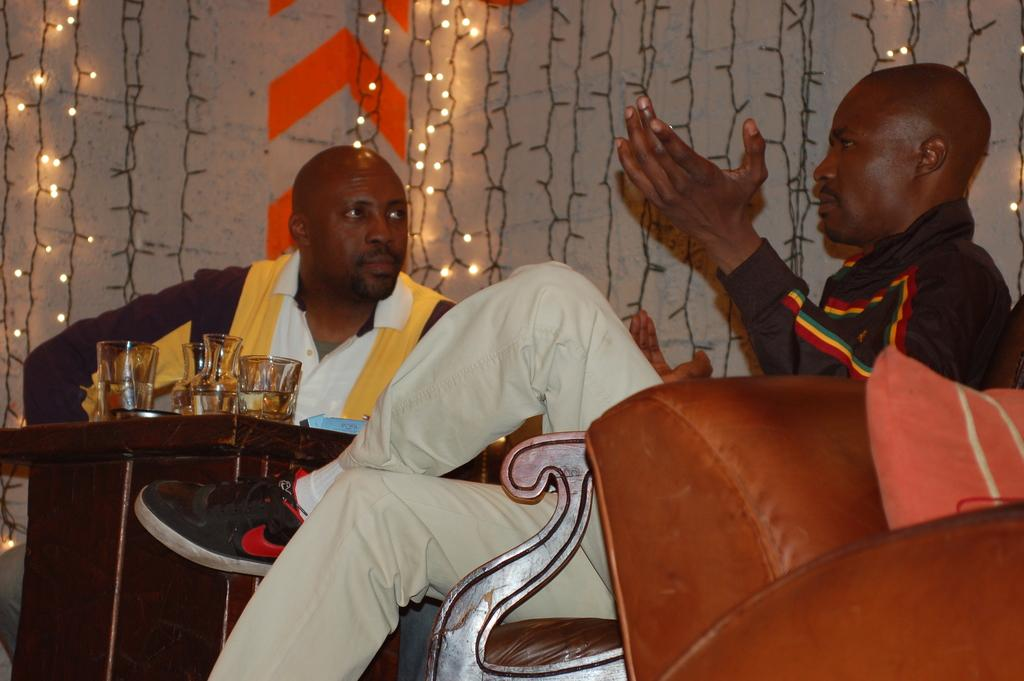How many men are in the image? There are two bald-headed men in the image. What are the men doing in the image? The men are sitting on a sofa. What is in front of the sofa? There is a table in front of the sofa. What is on the table? There are wine glasses on the table. What can be seen on the back wall? There are lights on the back wall. What flavor of wine is being served in the glasses on the table? There is no information about the flavor of the wine in the image, as it only shows wine glasses on the table. 